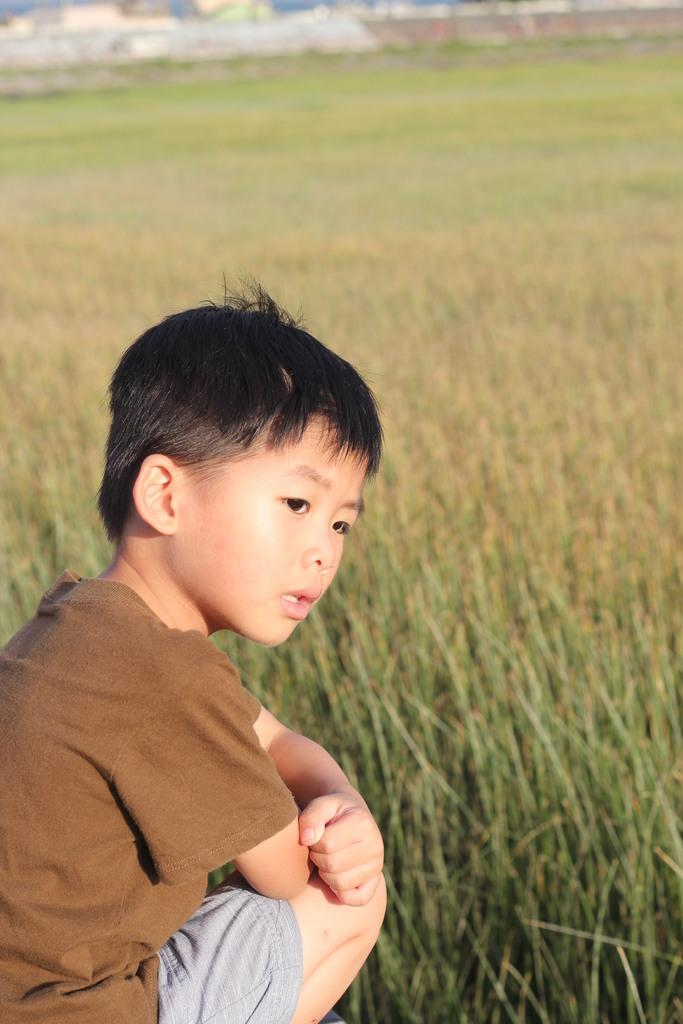What is the main subject of the image? The main subject of the image is a crop field. Can you describe anything else in the image? Yes, there is a kid in the bottom left of the image. What is the kid wearing? The kid is wearing clothes. What type of gold can be seen in the image? There is no gold present in the image. How many cows are grazing in the crop field? There are no cows visible in the image; it only features a crop field and a kid. 